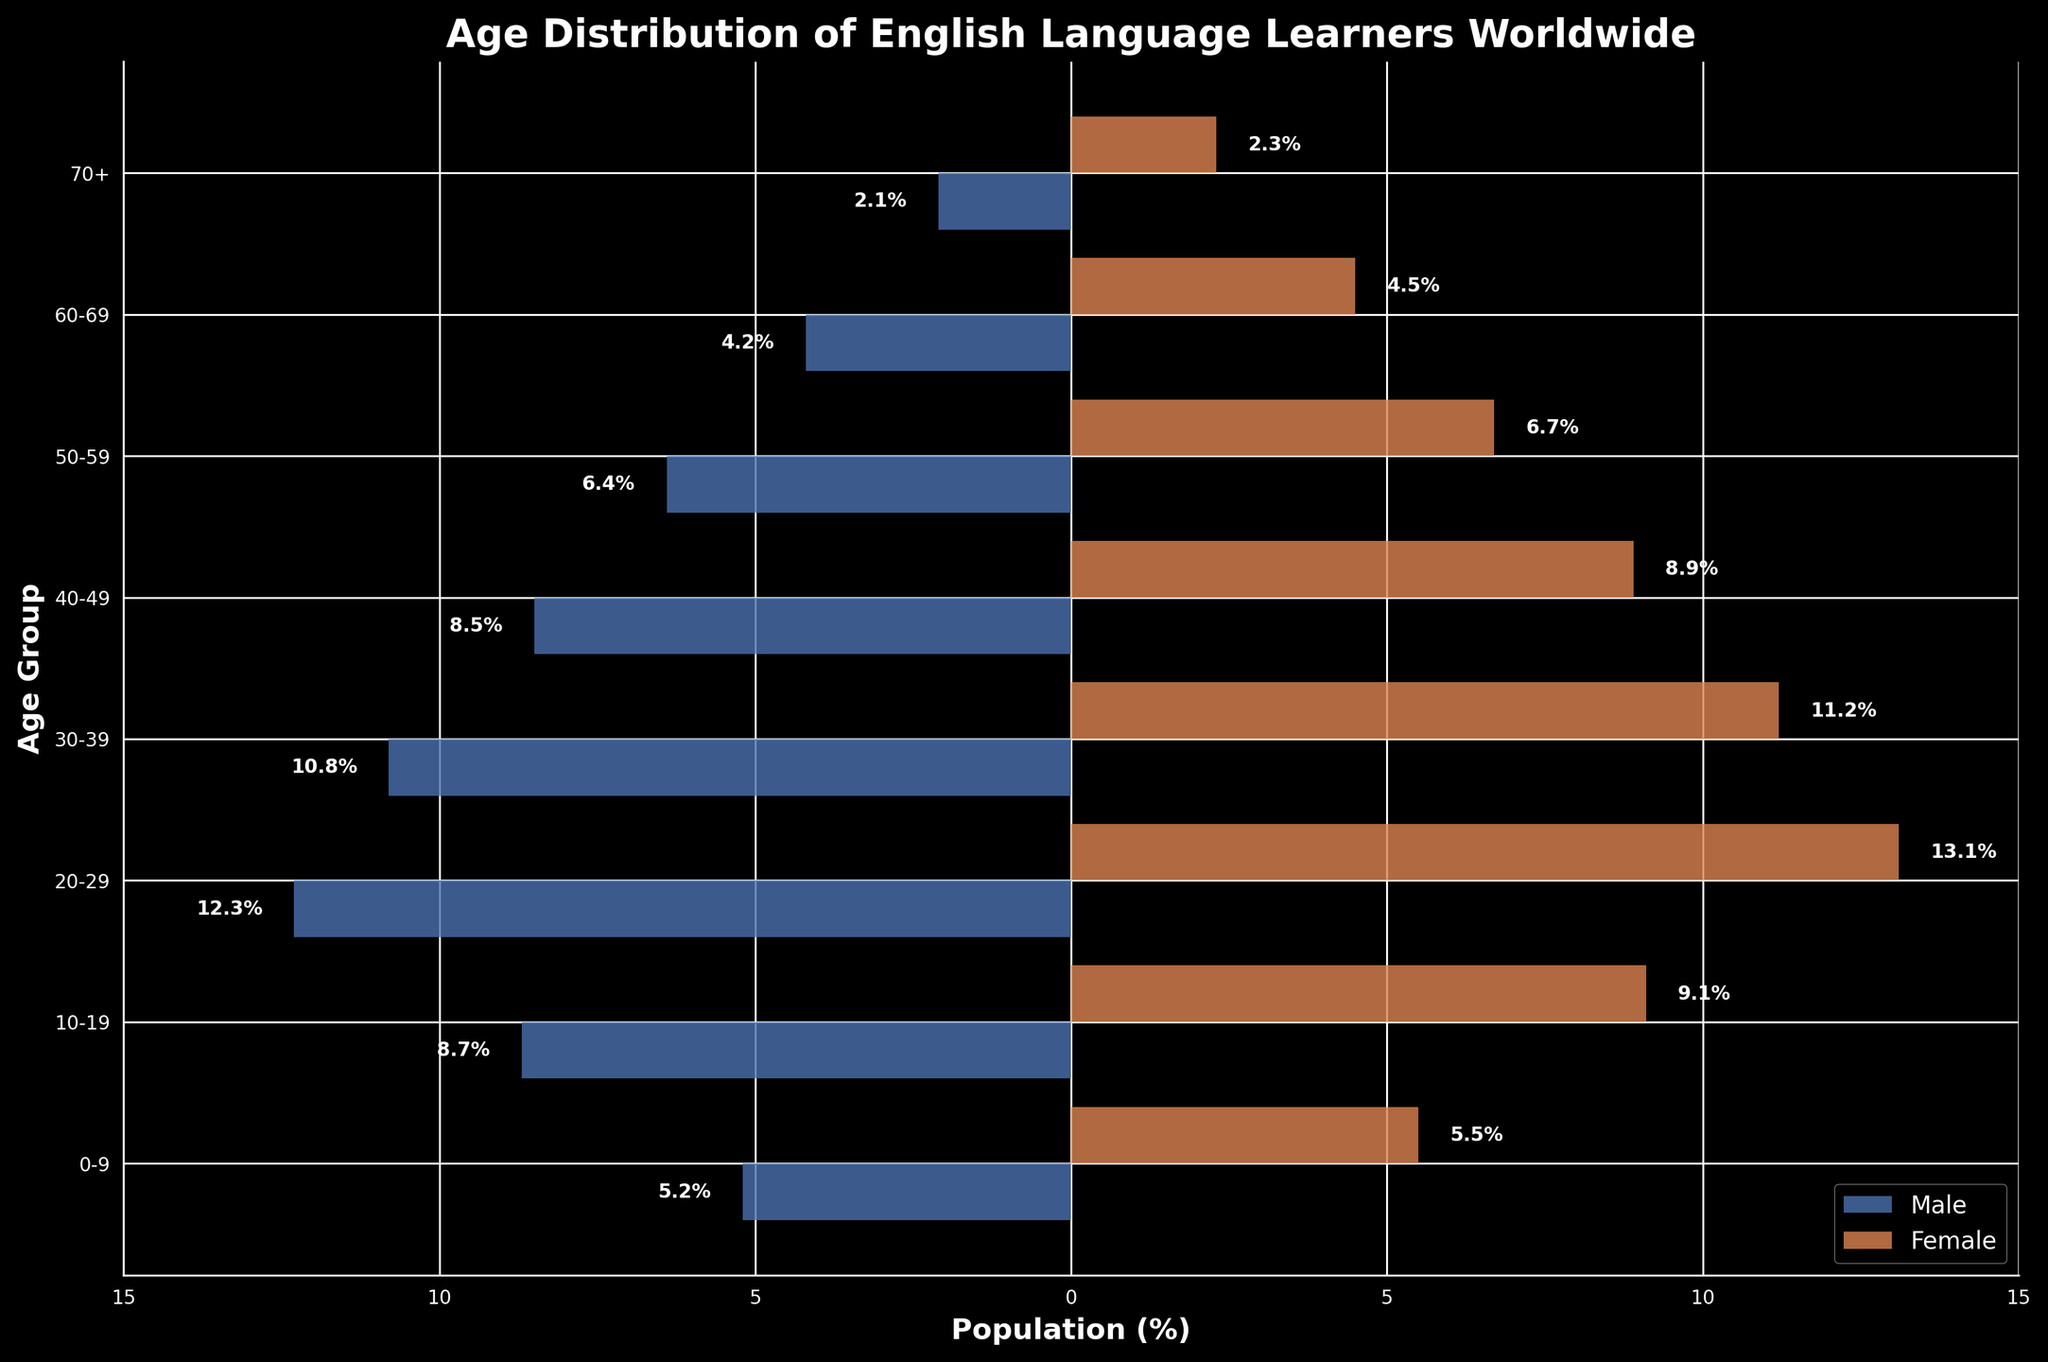What is the age group with the highest percentage of female English language learners? By observing the figure, we can see that the "20-29" age group has the highest percentage bar for females, which is labeled as 13.1%.
Answer: 20-29 Which age group has a higher male population percentage than the female population percentage? By looking at the figure, all age groups have a higher percentage for females. Therefore, there is no age group where males have a higher population percentage.
Answer: None How does the percentage of male learners aged 50-59 compare to those aged 40-49? The percentage for males aged 50-59 is 6.4%, and for those aged 40-49, it is 8.5%. So, 40-49 has a higher percentage.
Answer: Higher in 40-49 What is the total percentage of English language learners (both male and female) in the "10-19" age group? The male percentage in the "10-19" age group is 8.7%, and the female percentage is 9.1%. Adding these yields 8.7% + 9.1% = 17.8%.
Answer: 17.8% In which age group is the difference between male and female learners the smallest? Observing the bars and their labeled values, the age group "0-9" has males at 5.2% and females at 5.5%, resulting in a difference of 0.3%, which is the smallest.
Answer: 0-9 What is the combined percentage of learners above the age of 60? Summing the percentages for both genders: 60-69 males: 4.2%, 60-69 females: 4.5%, 70+ males: 2.1%, 70+ females: 2.3%. Thus, total = 4.2% + 4.5% + 2.1% + 2.3% = 13.1%.
Answer: 13.1% Which gender has a higher percentage in the "30-39" age group? By observing the figure, the female percentage in the "30-39" age group is labeled as 11.2%, while the male percentage is 10.8%, indicating females have a higher percentage.
Answer: Female Between the age groups "20-29" and "40-49", which has a larger total percentage of English language learners? The total percentage for "20-29" is 12.3% (male) + 13.1% (female) = 25.4%. For "40-49," it is 8.5% (male) + 8.9% (female) = 17.4%. Hence, "20-29" has a larger total percentage.
Answer: 20-29 What percentage of learners fall into the "70+" age group? By adding the values for both males and females in the "70+" group, we get 2.1% (male) + 2.3% (female) = 4.4%.
Answer: 4.4% What is the ratio of male learners to female learners in the "60-69" age group? The male percentage in the "60-69" age group is 4.2%, and the female percentage is 4.5%. Therefore, the ratio is 4.2:4.5. Simplifying, we divide both by the common factor, resulting in a ratio of 14:15.
Answer: 14:15 